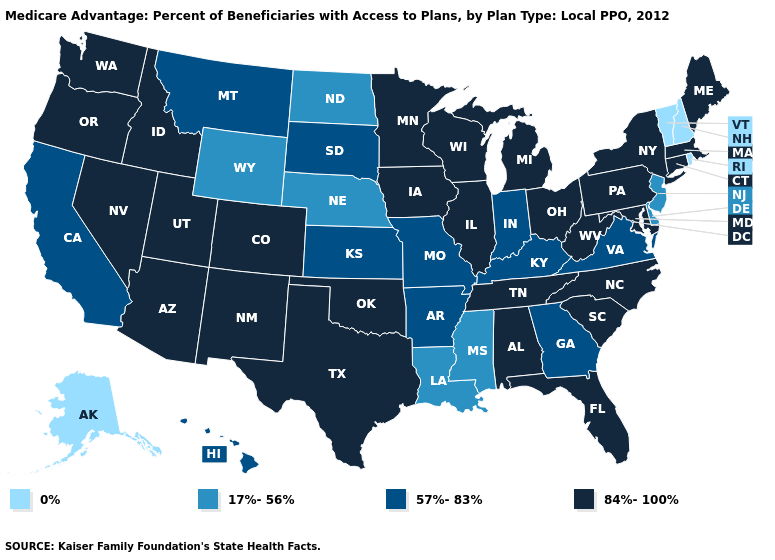What is the lowest value in states that border Missouri?
Answer briefly. 17%-56%. Does Nevada have a lower value than Oregon?
Be succinct. No. Does California have the lowest value in the West?
Short answer required. No. What is the value of New Jersey?
Quick response, please. 17%-56%. Among the states that border Rhode Island , which have the highest value?
Be succinct. Connecticut, Massachusetts. Does Minnesota have the highest value in the USA?
Keep it brief. Yes. What is the highest value in the West ?
Keep it brief. 84%-100%. Which states hav the highest value in the West?
Give a very brief answer. Arizona, Colorado, Idaho, New Mexico, Nevada, Oregon, Utah, Washington. What is the value of Iowa?
Concise answer only. 84%-100%. Name the states that have a value in the range 84%-100%?
Keep it brief. Alabama, Arizona, Colorado, Connecticut, Florida, Iowa, Idaho, Illinois, Massachusetts, Maryland, Maine, Michigan, Minnesota, North Carolina, New Mexico, Nevada, New York, Ohio, Oklahoma, Oregon, Pennsylvania, South Carolina, Tennessee, Texas, Utah, Washington, Wisconsin, West Virginia. Which states have the highest value in the USA?
Answer briefly. Alabama, Arizona, Colorado, Connecticut, Florida, Iowa, Idaho, Illinois, Massachusetts, Maryland, Maine, Michigan, Minnesota, North Carolina, New Mexico, Nevada, New York, Ohio, Oklahoma, Oregon, Pennsylvania, South Carolina, Tennessee, Texas, Utah, Washington, Wisconsin, West Virginia. Does West Virginia have the lowest value in the USA?
Be succinct. No. What is the highest value in states that border West Virginia?
Be succinct. 84%-100%. Which states have the lowest value in the West?
Give a very brief answer. Alaska. What is the value of Hawaii?
Write a very short answer. 57%-83%. 